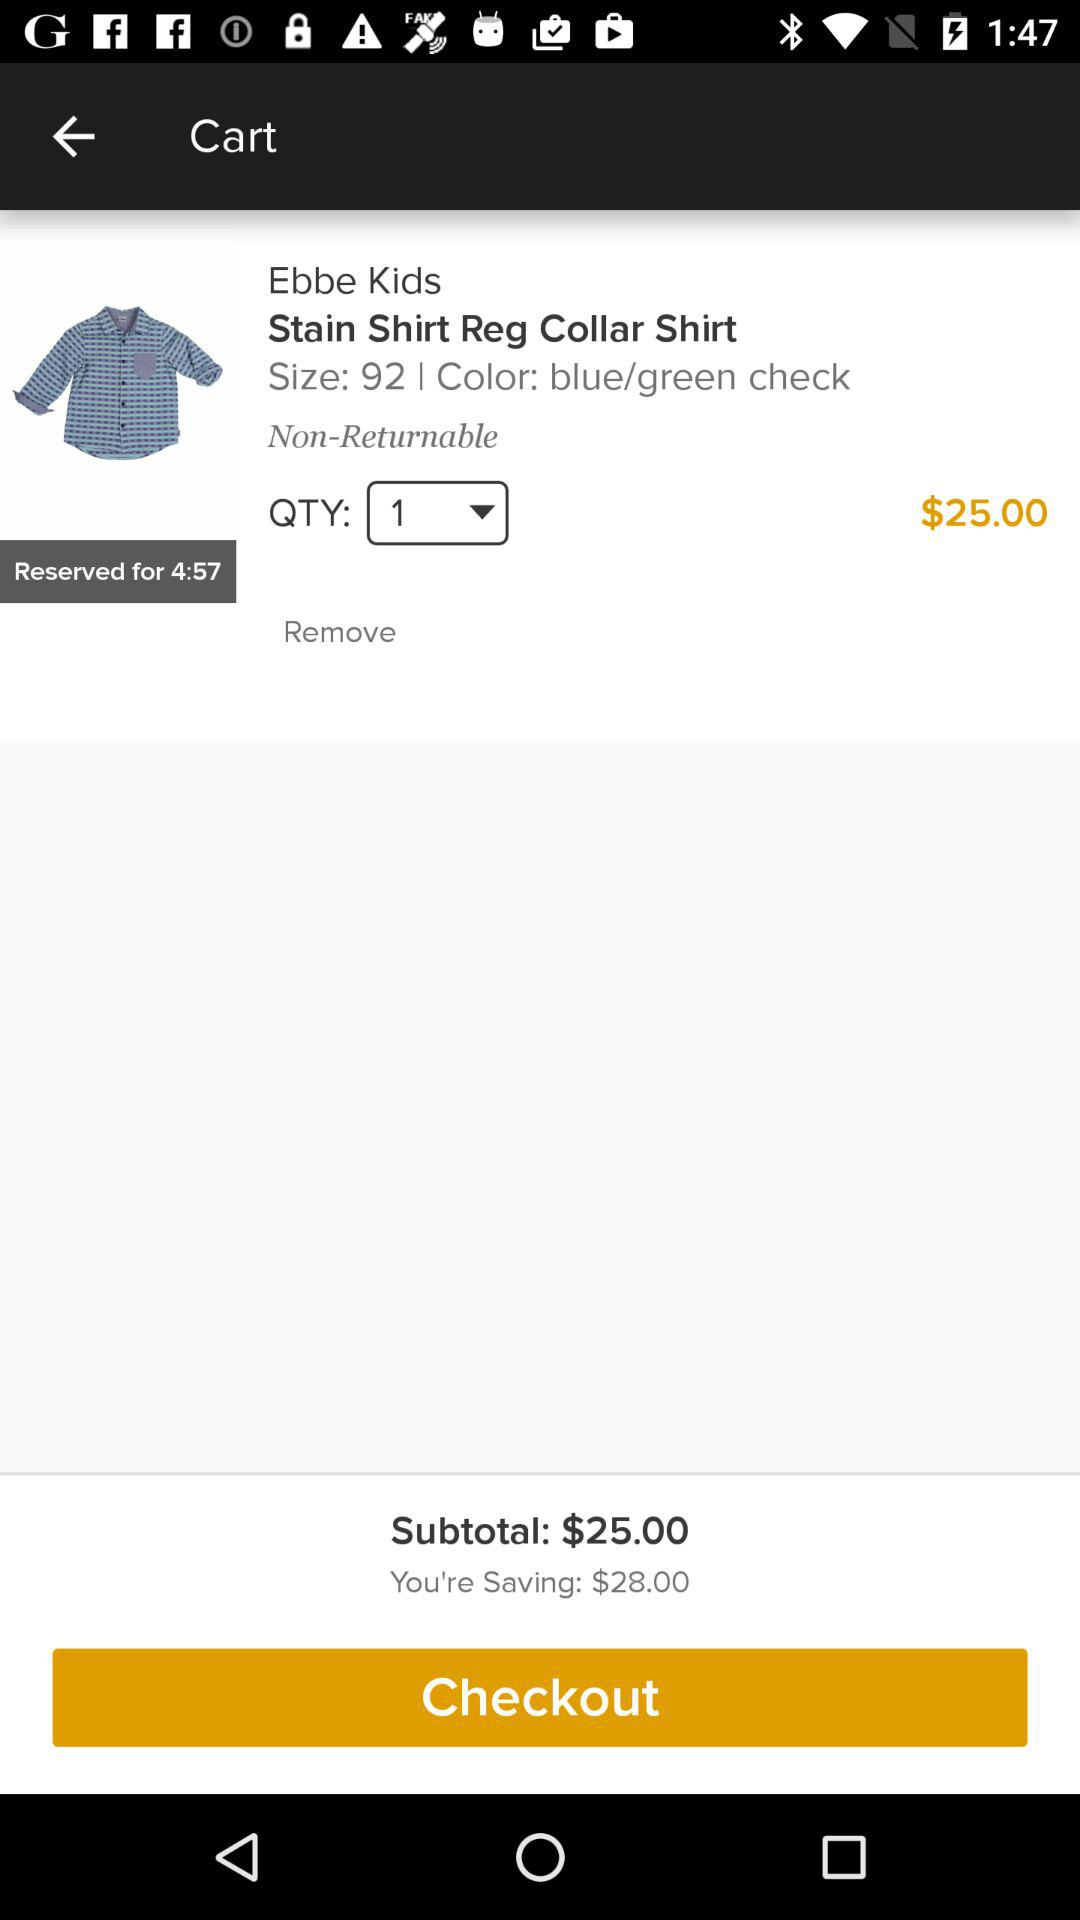How much money am I saving on this purchase?
Answer the question using a single word or phrase. $28.00 